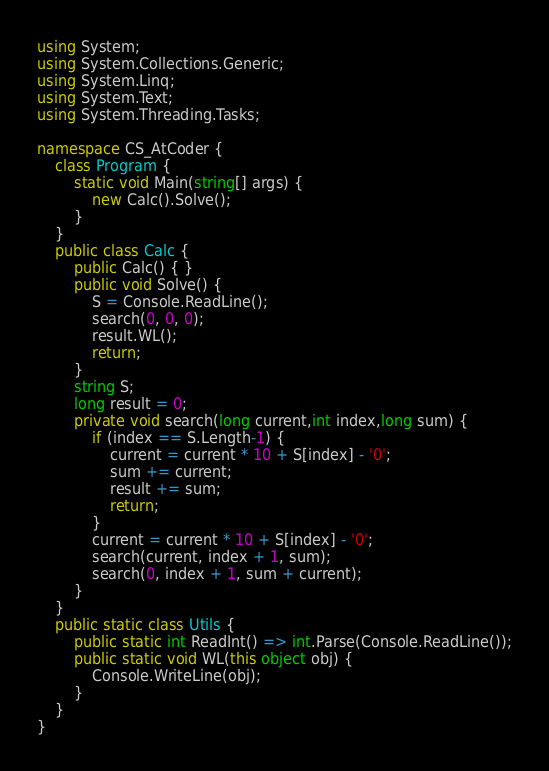Convert code to text. <code><loc_0><loc_0><loc_500><loc_500><_C#_>using System;
using System.Collections.Generic;
using System.Linq;
using System.Text;
using System.Threading.Tasks;

namespace CS_AtCoder {
	class Program {
		static void Main(string[] args) {
			new Calc().Solve();
		}
	}
	public class Calc {
		public Calc() { }
		public void Solve() {
			S = Console.ReadLine();
			search(0, 0, 0);
			result.WL();
			return;
		}
		string S;
		long result = 0;
		private void search(long current,int index,long sum) {
			if (index == S.Length-1) {
				current = current * 10 + S[index] - '0';
				sum += current;
				result += sum;
				return;
			}
			current = current * 10 + S[index] - '0';
			search(current, index + 1, sum);
			search(0, index + 1, sum + current);
		}
	}
	public static class Utils {
		public static int ReadInt() => int.Parse(Console.ReadLine());
		public static void WL(this object obj) {
			Console.WriteLine(obj);
		}
	}
}
</code> 